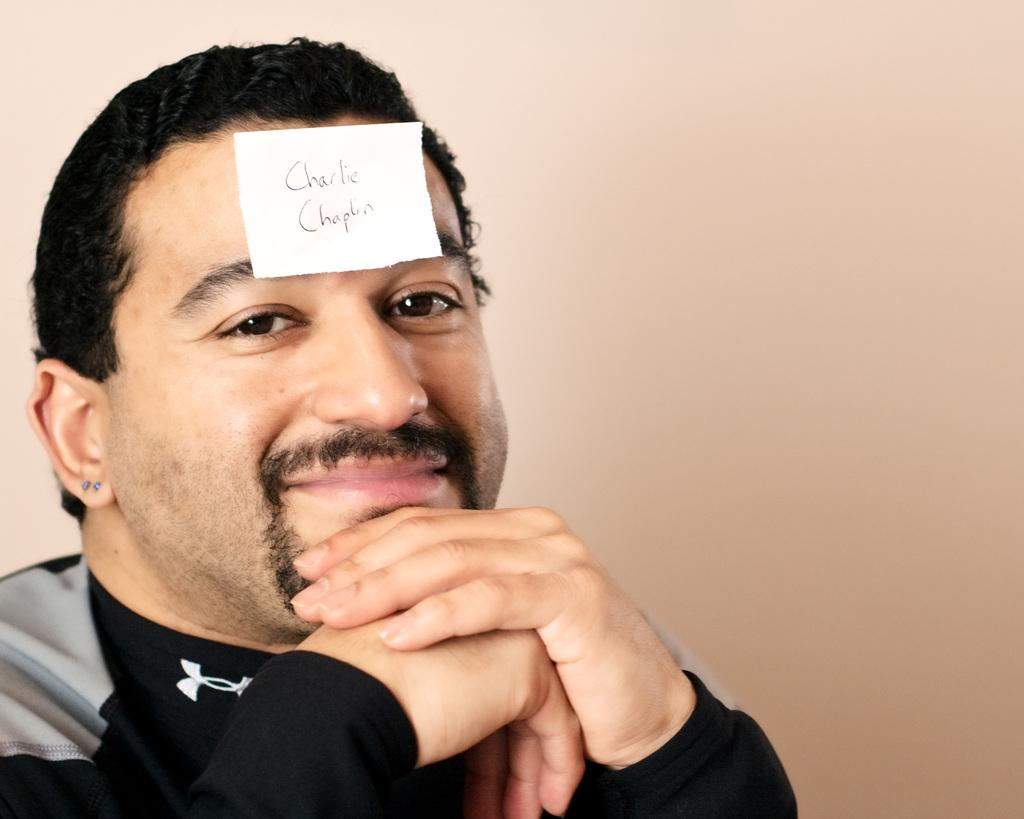Who is present in the image? There is a man in the image. What is the man doing in the image? The man is smiling in the image. What object is placed on the man's forehead? There is a piece of paper with text written on it in the image. How many frogs are hopping on the train in the image? There is no train or frogs present in the image. What color is the rose on the man's lapel in the image? There is no rose present in the image. 